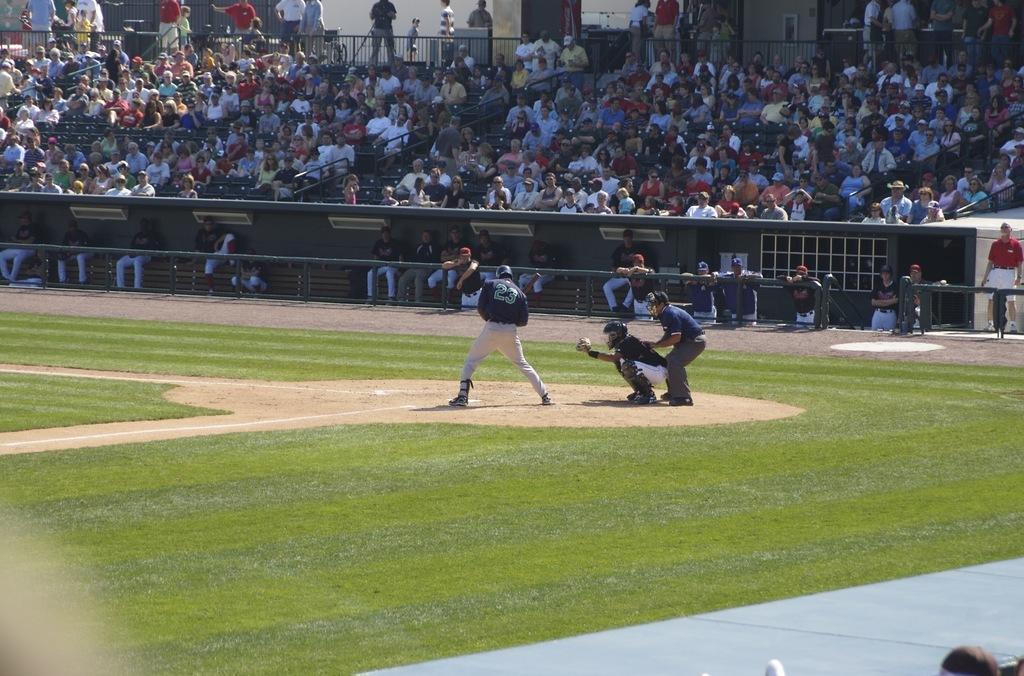Can you describe this image briefly? In this image we can see people playing a game. In the background there is crowd sitting and some of them are standing. There is a fence. At the bottom there is ground. 